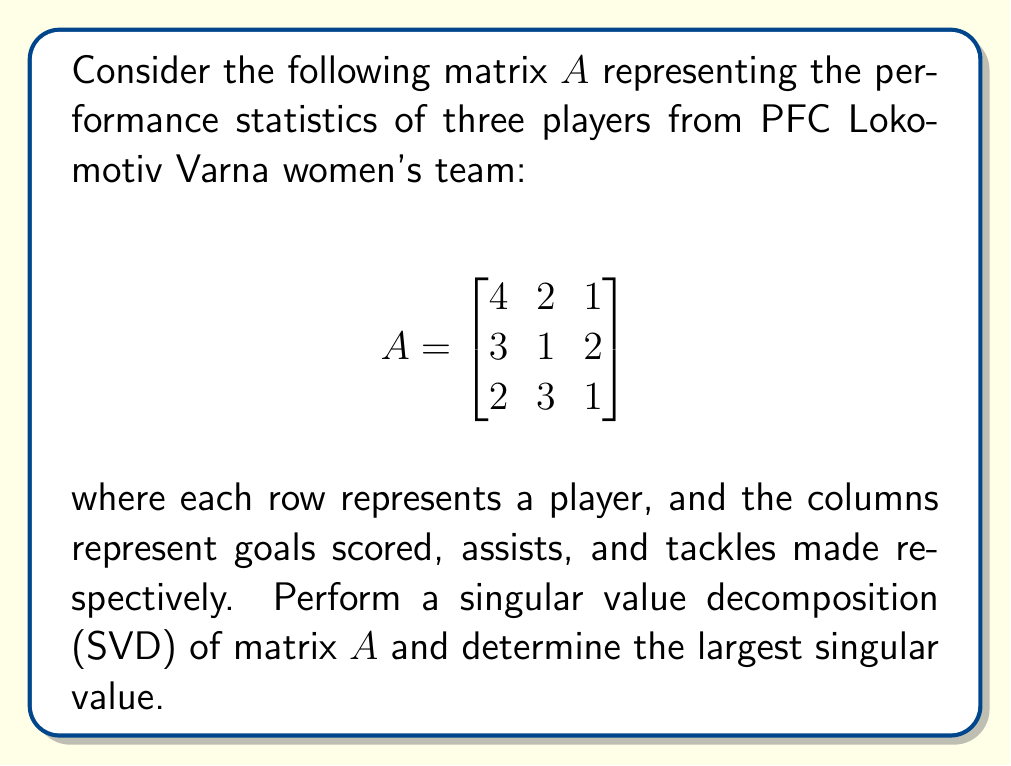Help me with this question. To find the singular value decomposition of matrix $A$, we need to follow these steps:

1) First, calculate $A^TA$:
   $$A^TA = \begin{bmatrix}
   4 & 3 & 2 \\
   2 & 1 & 3 \\
   1 & 2 & 1
   \end{bmatrix} \begin{bmatrix}
   4 & 2 & 1 \\
   3 & 1 & 2 \\
   2 & 3 & 1
   \end{bmatrix} = \begin{bmatrix}
   29 & 17 & 13 \\
   17 & 14 & 9 \\
   13 & 9 & 10
   \end{bmatrix}$$

2) Find the eigenvalues of $A^TA$ by solving the characteristic equation:
   $\det(A^TA - \lambda I) = 0$
   
   This gives us the cubic equation:
   $-\lambda^3 + 53\lambda^2 - 806\lambda + 3380 = 0$

3) Solving this equation (using a calculator or computer algebra system) gives us the eigenvalues:
   $\lambda_1 \approx 45.7925$, $\lambda_2 \approx 5.9741$, $\lambda_3 \approx 1.2334$

4) The singular values are the square roots of these eigenvalues:
   $\sigma_1 \approx \sqrt{45.7925} \approx 6.7669$
   $\sigma_2 \approx \sqrt{5.9741} \approx 2.4442$
   $\sigma_3 \approx \sqrt{1.2334} \approx 1.1106$

5) The largest singular value is $\sigma_1 \approx 6.7669$.

Note: The full SVD would also involve calculating the left and right singular vectors, but the question only asks for the largest singular value.
Answer: $6.7669$ (rounded to 4 decimal places) 